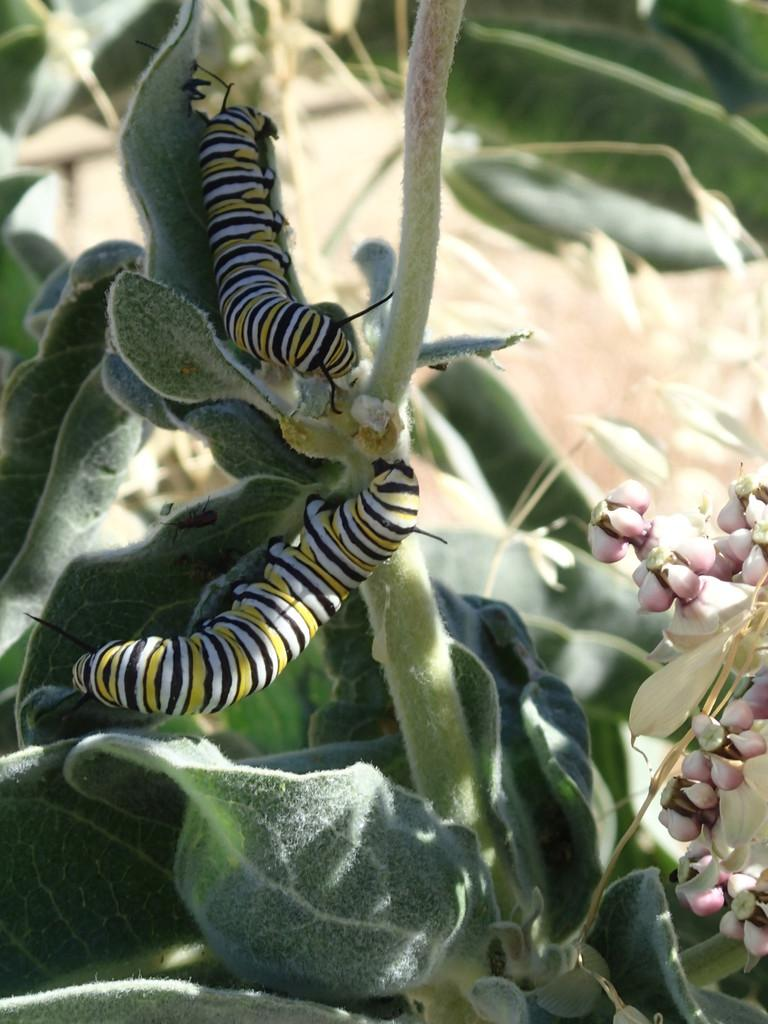What type of creatures can be seen in the image? There are insects and bugs in the image. What else is present in the image besides insects and bugs? There are plants in the image. What type of sock is being used to coach the insects in the image? There is no sock or coaching activity present in the image. 